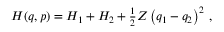<formula> <loc_0><loc_0><loc_500><loc_500>\begin{array} { r } { H ( q , p ) = H _ { 1 } + H _ { 2 } + \frac { 1 } { 2 } Z \left ( q _ { 1 } - q _ { 2 } \right ) ^ { 2 } \, , } \end{array}</formula> 